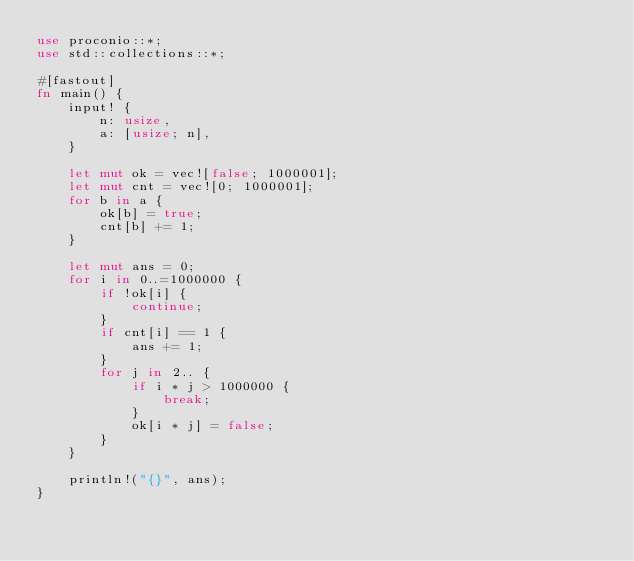Convert code to text. <code><loc_0><loc_0><loc_500><loc_500><_Rust_>use proconio::*;
use std::collections::*;

#[fastout]
fn main() {
    input! {
        n: usize,
        a: [usize; n],
    }

    let mut ok = vec![false; 1000001];
    let mut cnt = vec![0; 1000001];
    for b in a {
        ok[b] = true;
        cnt[b] += 1;
    }

    let mut ans = 0;
    for i in 0..=1000000 {
        if !ok[i] {
            continue;
        }
        if cnt[i] == 1 {
            ans += 1;
        }
        for j in 2.. {
            if i * j > 1000000 {
                break;
            }
            ok[i * j] = false;
        }
    }

    println!("{}", ans);
}
</code> 